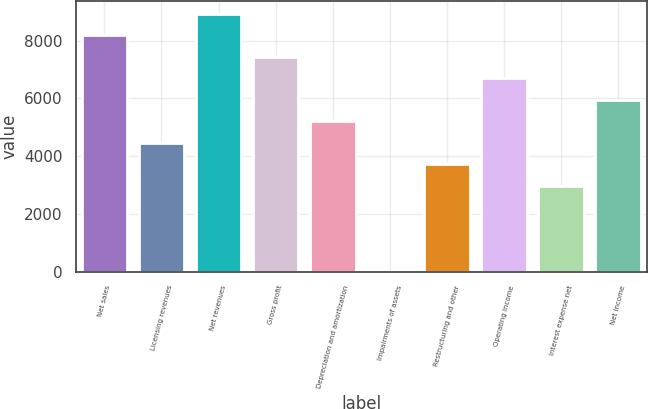<chart> <loc_0><loc_0><loc_500><loc_500><bar_chart><fcel>Net sales<fcel>Licensing revenues<fcel>Net revenues<fcel>Gross profit<fcel>Depreciation and amortization<fcel>Impairments of assets<fcel>Restructuring and other<fcel>Operating income<fcel>Interest expense net<fcel>Net income<nl><fcel>8194.9<fcel>4470.4<fcel>8939.8<fcel>7450<fcel>5215.3<fcel>1<fcel>3725.5<fcel>6705.1<fcel>2980.6<fcel>5960.2<nl></chart> 